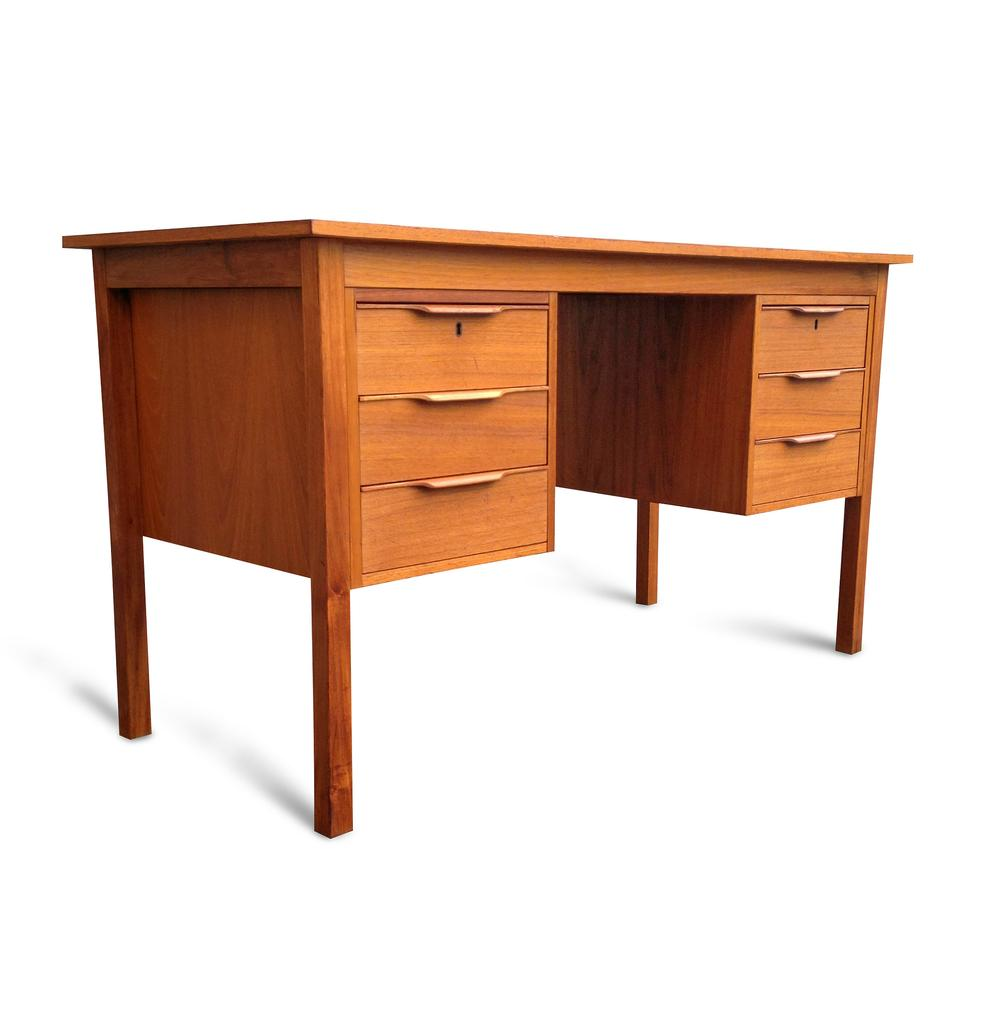What type of furniture is present in the image? There is a table in the image. Can you find the letter that the table is using to communicate with the chairs in the image? There is no letter present in the image, nor is there any indication that the table or chairs are communicating with each other. 